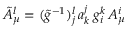Convert formula to latex. <formula><loc_0><loc_0><loc_500><loc_500>\tilde { A } _ { \mu } ^ { l } = ( \tilde { g } ^ { - 1 } _ { j } ^ { l } \, a _ { k } ^ { j } \, g _ { i } ^ { k } \, A _ { \mu } ^ { i }</formula> 